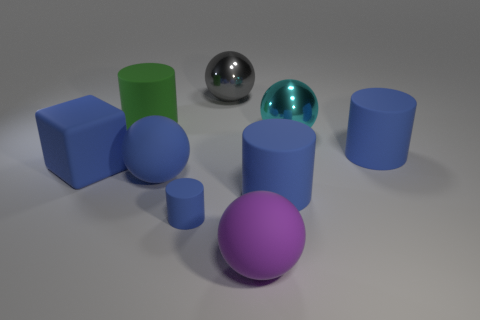Is there a matte cube of the same color as the tiny rubber object?
Keep it short and to the point. Yes. There is a big gray object that is the same material as the cyan thing; what is its shape?
Make the answer very short. Sphere. Are any big blue things visible?
Your answer should be compact. Yes. Are there fewer tiny matte cylinders that are on the left side of the large cube than small matte cylinders on the right side of the purple object?
Give a very brief answer. No. What shape is the tiny blue thing to the right of the blue rubber block?
Make the answer very short. Cylinder. Are the big blue sphere and the big cyan object made of the same material?
Ensure brevity in your answer.  No. What is the material of the purple thing that is the same shape as the cyan object?
Your answer should be compact. Rubber. Is the number of tiny objects that are to the left of the large green object less than the number of big cyan matte cylinders?
Provide a short and direct response. No. There is a large blue matte sphere; what number of big cylinders are right of it?
Make the answer very short. 2. Is the shape of the large rubber object that is in front of the small matte cylinder the same as the cyan shiny thing that is on the right side of the big purple object?
Give a very brief answer. Yes. 